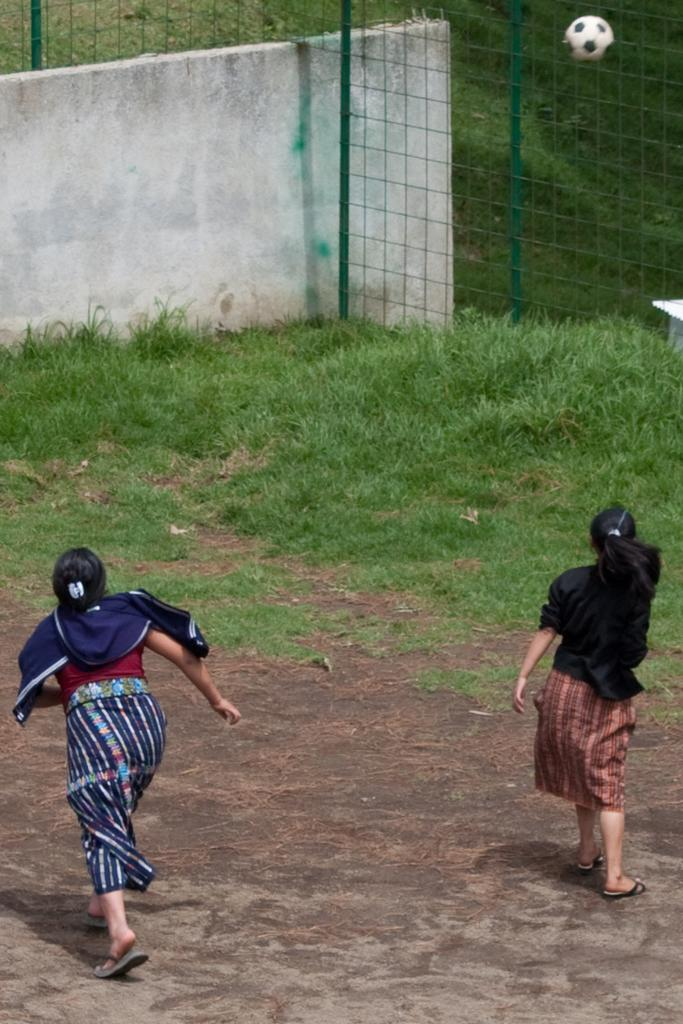What are the women in the image doing? The women in the image are running. What type of surface are the women running on? There is grass on the ground in the image. What object is in the air in the image? There is a football in the air in the image. What is located on the right side of the image? There is a metal fence on the right side of the image. What type of seed is being planted in the image? There is no seed being planted in the image; the focus is on the women running and the football in the air. What can be used to light a match in the image? There is no match or any object related to lighting a match present in the image. 